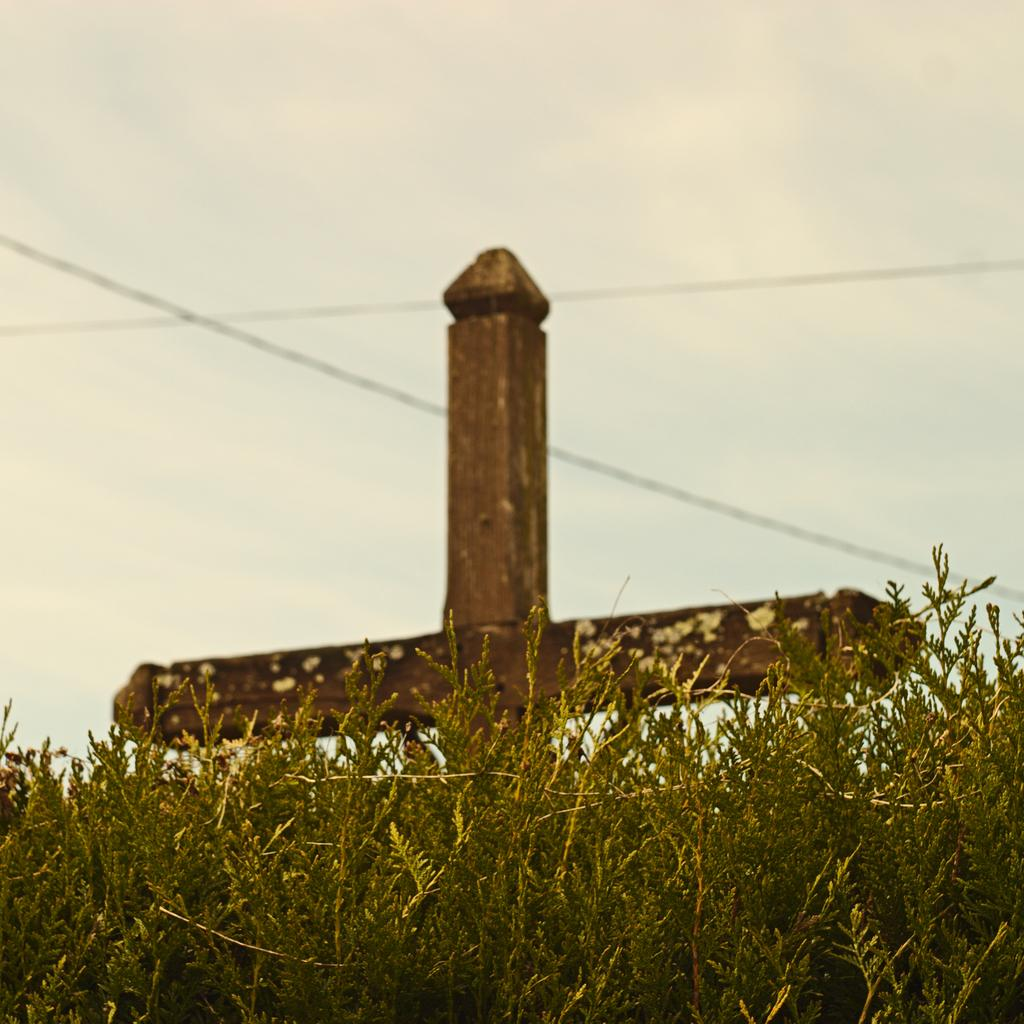What type of living organisms can be seen in the image? Plants can be seen in the image. What color are the plants in the image? The plants are green in color. What other objects can be seen in the image besides the plants? There is a brown-colored pole and wires in the image. What is visible part of the natural environment can be seen in the image? The sky is visible in the background of the image. What type of marble is used to construct the nation's buildings in the image? There is no mention of marble or buildings in the image; it features plants, a brown-colored pole, wires, and the sky. 